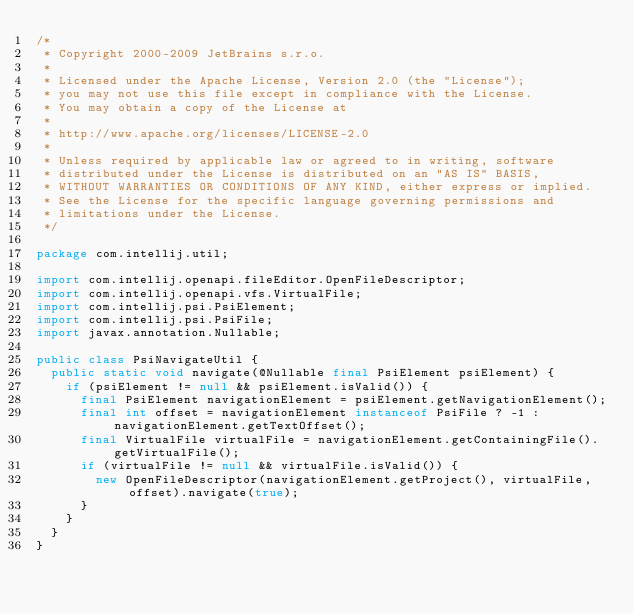<code> <loc_0><loc_0><loc_500><loc_500><_Java_>/*
 * Copyright 2000-2009 JetBrains s.r.o.
 *
 * Licensed under the Apache License, Version 2.0 (the "License");
 * you may not use this file except in compliance with the License.
 * You may obtain a copy of the License at
 *
 * http://www.apache.org/licenses/LICENSE-2.0
 *
 * Unless required by applicable law or agreed to in writing, software
 * distributed under the License is distributed on an "AS IS" BASIS,
 * WITHOUT WARRANTIES OR CONDITIONS OF ANY KIND, either express or implied.
 * See the License for the specific language governing permissions and
 * limitations under the License.
 */

package com.intellij.util;

import com.intellij.openapi.fileEditor.OpenFileDescriptor;
import com.intellij.openapi.vfs.VirtualFile;
import com.intellij.psi.PsiElement;
import com.intellij.psi.PsiFile;
import javax.annotation.Nullable;

public class PsiNavigateUtil {
  public static void navigate(@Nullable final PsiElement psiElement) {
    if (psiElement != null && psiElement.isValid()) {
      final PsiElement navigationElement = psiElement.getNavigationElement();
      final int offset = navigationElement instanceof PsiFile ? -1 : navigationElement.getTextOffset();
      final VirtualFile virtualFile = navigationElement.getContainingFile().getVirtualFile();
      if (virtualFile != null && virtualFile.isValid()) {
        new OpenFileDescriptor(navigationElement.getProject(), virtualFile, offset).navigate(true);
      }
    }
  }
}</code> 